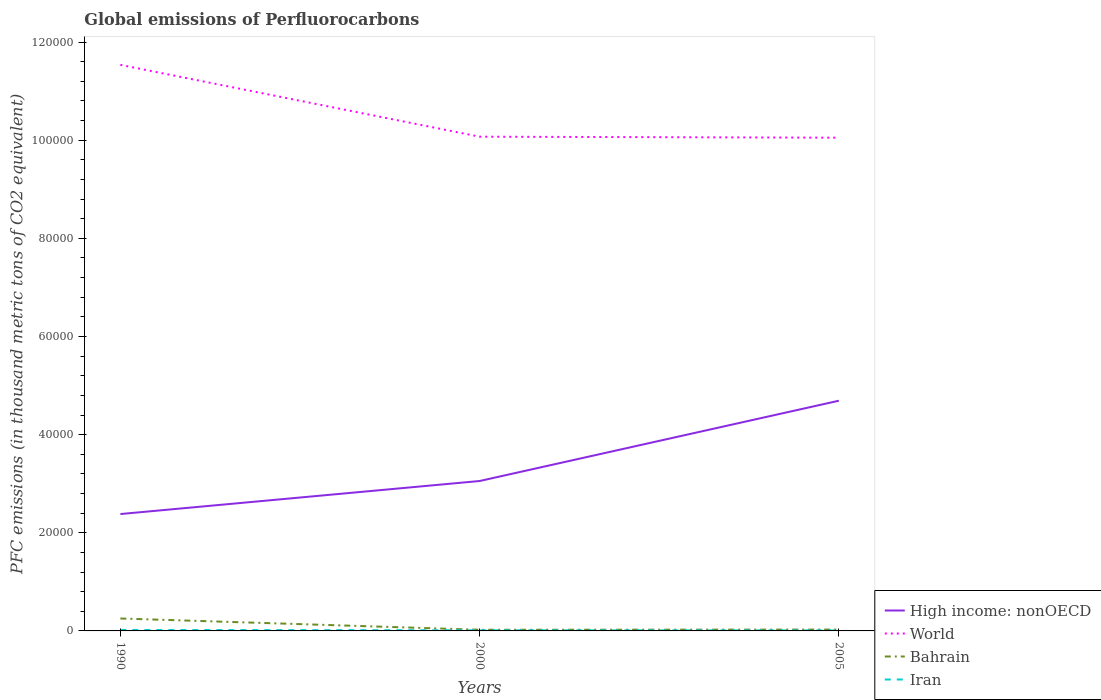Is the number of lines equal to the number of legend labels?
Ensure brevity in your answer.  Yes. Across all years, what is the maximum global emissions of Perfluorocarbons in Bahrain?
Make the answer very short. 236.1. What is the total global emissions of Perfluorocarbons in World in the graph?
Give a very brief answer. 1.46e+04. What is the difference between the highest and the second highest global emissions of Perfluorocarbons in High income: nonOECD?
Make the answer very short. 2.31e+04. Is the global emissions of Perfluorocarbons in Iran strictly greater than the global emissions of Perfluorocarbons in Bahrain over the years?
Keep it short and to the point. Yes. How many years are there in the graph?
Give a very brief answer. 3. Are the values on the major ticks of Y-axis written in scientific E-notation?
Offer a terse response. No. Does the graph contain grids?
Provide a short and direct response. No. How many legend labels are there?
Give a very brief answer. 4. What is the title of the graph?
Offer a very short reply. Global emissions of Perfluorocarbons. Does "Malaysia" appear as one of the legend labels in the graph?
Keep it short and to the point. No. What is the label or title of the Y-axis?
Give a very brief answer. PFC emissions (in thousand metric tons of CO2 equivalent). What is the PFC emissions (in thousand metric tons of CO2 equivalent) in High income: nonOECD in 1990?
Ensure brevity in your answer.  2.38e+04. What is the PFC emissions (in thousand metric tons of CO2 equivalent) of World in 1990?
Ensure brevity in your answer.  1.15e+05. What is the PFC emissions (in thousand metric tons of CO2 equivalent) in Bahrain in 1990?
Provide a succinct answer. 2535.7. What is the PFC emissions (in thousand metric tons of CO2 equivalent) in Iran in 1990?
Your answer should be compact. 203.5. What is the PFC emissions (in thousand metric tons of CO2 equivalent) of High income: nonOECD in 2000?
Offer a very short reply. 3.06e+04. What is the PFC emissions (in thousand metric tons of CO2 equivalent) of World in 2000?
Offer a very short reply. 1.01e+05. What is the PFC emissions (in thousand metric tons of CO2 equivalent) of Bahrain in 2000?
Offer a very short reply. 236.1. What is the PFC emissions (in thousand metric tons of CO2 equivalent) of Iran in 2000?
Keep it short and to the point. 128.5. What is the PFC emissions (in thousand metric tons of CO2 equivalent) in High income: nonOECD in 2005?
Offer a terse response. 4.69e+04. What is the PFC emissions (in thousand metric tons of CO2 equivalent) in World in 2005?
Your answer should be very brief. 1.01e+05. What is the PFC emissions (in thousand metric tons of CO2 equivalent) in Bahrain in 2005?
Offer a terse response. 278.6. What is the PFC emissions (in thousand metric tons of CO2 equivalent) in Iran in 2005?
Your answer should be very brief. 108.5. Across all years, what is the maximum PFC emissions (in thousand metric tons of CO2 equivalent) of High income: nonOECD?
Offer a terse response. 4.69e+04. Across all years, what is the maximum PFC emissions (in thousand metric tons of CO2 equivalent) in World?
Provide a succinct answer. 1.15e+05. Across all years, what is the maximum PFC emissions (in thousand metric tons of CO2 equivalent) of Bahrain?
Provide a succinct answer. 2535.7. Across all years, what is the maximum PFC emissions (in thousand metric tons of CO2 equivalent) in Iran?
Keep it short and to the point. 203.5. Across all years, what is the minimum PFC emissions (in thousand metric tons of CO2 equivalent) in High income: nonOECD?
Make the answer very short. 2.38e+04. Across all years, what is the minimum PFC emissions (in thousand metric tons of CO2 equivalent) of World?
Your answer should be very brief. 1.01e+05. Across all years, what is the minimum PFC emissions (in thousand metric tons of CO2 equivalent) of Bahrain?
Give a very brief answer. 236.1. Across all years, what is the minimum PFC emissions (in thousand metric tons of CO2 equivalent) of Iran?
Provide a succinct answer. 108.5. What is the total PFC emissions (in thousand metric tons of CO2 equivalent) in High income: nonOECD in the graph?
Keep it short and to the point. 1.01e+05. What is the total PFC emissions (in thousand metric tons of CO2 equivalent) in World in the graph?
Keep it short and to the point. 3.17e+05. What is the total PFC emissions (in thousand metric tons of CO2 equivalent) of Bahrain in the graph?
Provide a short and direct response. 3050.4. What is the total PFC emissions (in thousand metric tons of CO2 equivalent) of Iran in the graph?
Your answer should be compact. 440.5. What is the difference between the PFC emissions (in thousand metric tons of CO2 equivalent) of High income: nonOECD in 1990 and that in 2000?
Your response must be concise. -6731.3. What is the difference between the PFC emissions (in thousand metric tons of CO2 equivalent) of World in 1990 and that in 2000?
Keep it short and to the point. 1.46e+04. What is the difference between the PFC emissions (in thousand metric tons of CO2 equivalent) in Bahrain in 1990 and that in 2000?
Ensure brevity in your answer.  2299.6. What is the difference between the PFC emissions (in thousand metric tons of CO2 equivalent) in High income: nonOECD in 1990 and that in 2005?
Your answer should be very brief. -2.31e+04. What is the difference between the PFC emissions (in thousand metric tons of CO2 equivalent) of World in 1990 and that in 2005?
Provide a succinct answer. 1.48e+04. What is the difference between the PFC emissions (in thousand metric tons of CO2 equivalent) of Bahrain in 1990 and that in 2005?
Your answer should be very brief. 2257.1. What is the difference between the PFC emissions (in thousand metric tons of CO2 equivalent) in Iran in 1990 and that in 2005?
Offer a terse response. 95. What is the difference between the PFC emissions (in thousand metric tons of CO2 equivalent) of High income: nonOECD in 2000 and that in 2005?
Keep it short and to the point. -1.64e+04. What is the difference between the PFC emissions (in thousand metric tons of CO2 equivalent) of World in 2000 and that in 2005?
Make the answer very short. 203. What is the difference between the PFC emissions (in thousand metric tons of CO2 equivalent) of Bahrain in 2000 and that in 2005?
Your response must be concise. -42.5. What is the difference between the PFC emissions (in thousand metric tons of CO2 equivalent) in Iran in 2000 and that in 2005?
Keep it short and to the point. 20. What is the difference between the PFC emissions (in thousand metric tons of CO2 equivalent) in High income: nonOECD in 1990 and the PFC emissions (in thousand metric tons of CO2 equivalent) in World in 2000?
Your response must be concise. -7.69e+04. What is the difference between the PFC emissions (in thousand metric tons of CO2 equivalent) in High income: nonOECD in 1990 and the PFC emissions (in thousand metric tons of CO2 equivalent) in Bahrain in 2000?
Offer a terse response. 2.36e+04. What is the difference between the PFC emissions (in thousand metric tons of CO2 equivalent) in High income: nonOECD in 1990 and the PFC emissions (in thousand metric tons of CO2 equivalent) in Iran in 2000?
Your answer should be very brief. 2.37e+04. What is the difference between the PFC emissions (in thousand metric tons of CO2 equivalent) of World in 1990 and the PFC emissions (in thousand metric tons of CO2 equivalent) of Bahrain in 2000?
Make the answer very short. 1.15e+05. What is the difference between the PFC emissions (in thousand metric tons of CO2 equivalent) of World in 1990 and the PFC emissions (in thousand metric tons of CO2 equivalent) of Iran in 2000?
Offer a terse response. 1.15e+05. What is the difference between the PFC emissions (in thousand metric tons of CO2 equivalent) of Bahrain in 1990 and the PFC emissions (in thousand metric tons of CO2 equivalent) of Iran in 2000?
Your answer should be compact. 2407.2. What is the difference between the PFC emissions (in thousand metric tons of CO2 equivalent) of High income: nonOECD in 1990 and the PFC emissions (in thousand metric tons of CO2 equivalent) of World in 2005?
Your answer should be compact. -7.67e+04. What is the difference between the PFC emissions (in thousand metric tons of CO2 equivalent) of High income: nonOECD in 1990 and the PFC emissions (in thousand metric tons of CO2 equivalent) of Bahrain in 2005?
Your response must be concise. 2.35e+04. What is the difference between the PFC emissions (in thousand metric tons of CO2 equivalent) in High income: nonOECD in 1990 and the PFC emissions (in thousand metric tons of CO2 equivalent) in Iran in 2005?
Give a very brief answer. 2.37e+04. What is the difference between the PFC emissions (in thousand metric tons of CO2 equivalent) of World in 1990 and the PFC emissions (in thousand metric tons of CO2 equivalent) of Bahrain in 2005?
Your response must be concise. 1.15e+05. What is the difference between the PFC emissions (in thousand metric tons of CO2 equivalent) of World in 1990 and the PFC emissions (in thousand metric tons of CO2 equivalent) of Iran in 2005?
Provide a short and direct response. 1.15e+05. What is the difference between the PFC emissions (in thousand metric tons of CO2 equivalent) in Bahrain in 1990 and the PFC emissions (in thousand metric tons of CO2 equivalent) in Iran in 2005?
Provide a succinct answer. 2427.2. What is the difference between the PFC emissions (in thousand metric tons of CO2 equivalent) in High income: nonOECD in 2000 and the PFC emissions (in thousand metric tons of CO2 equivalent) in World in 2005?
Provide a short and direct response. -7.00e+04. What is the difference between the PFC emissions (in thousand metric tons of CO2 equivalent) of High income: nonOECD in 2000 and the PFC emissions (in thousand metric tons of CO2 equivalent) of Bahrain in 2005?
Your response must be concise. 3.03e+04. What is the difference between the PFC emissions (in thousand metric tons of CO2 equivalent) of High income: nonOECD in 2000 and the PFC emissions (in thousand metric tons of CO2 equivalent) of Iran in 2005?
Your response must be concise. 3.04e+04. What is the difference between the PFC emissions (in thousand metric tons of CO2 equivalent) of World in 2000 and the PFC emissions (in thousand metric tons of CO2 equivalent) of Bahrain in 2005?
Provide a succinct answer. 1.00e+05. What is the difference between the PFC emissions (in thousand metric tons of CO2 equivalent) of World in 2000 and the PFC emissions (in thousand metric tons of CO2 equivalent) of Iran in 2005?
Your answer should be compact. 1.01e+05. What is the difference between the PFC emissions (in thousand metric tons of CO2 equivalent) of Bahrain in 2000 and the PFC emissions (in thousand metric tons of CO2 equivalent) of Iran in 2005?
Your answer should be compact. 127.6. What is the average PFC emissions (in thousand metric tons of CO2 equivalent) of High income: nonOECD per year?
Offer a very short reply. 3.38e+04. What is the average PFC emissions (in thousand metric tons of CO2 equivalent) in World per year?
Offer a very short reply. 1.06e+05. What is the average PFC emissions (in thousand metric tons of CO2 equivalent) of Bahrain per year?
Provide a short and direct response. 1016.8. What is the average PFC emissions (in thousand metric tons of CO2 equivalent) of Iran per year?
Provide a succinct answer. 146.83. In the year 1990, what is the difference between the PFC emissions (in thousand metric tons of CO2 equivalent) in High income: nonOECD and PFC emissions (in thousand metric tons of CO2 equivalent) in World?
Make the answer very short. -9.15e+04. In the year 1990, what is the difference between the PFC emissions (in thousand metric tons of CO2 equivalent) of High income: nonOECD and PFC emissions (in thousand metric tons of CO2 equivalent) of Bahrain?
Keep it short and to the point. 2.13e+04. In the year 1990, what is the difference between the PFC emissions (in thousand metric tons of CO2 equivalent) in High income: nonOECD and PFC emissions (in thousand metric tons of CO2 equivalent) in Iran?
Provide a short and direct response. 2.36e+04. In the year 1990, what is the difference between the PFC emissions (in thousand metric tons of CO2 equivalent) of World and PFC emissions (in thousand metric tons of CO2 equivalent) of Bahrain?
Your answer should be very brief. 1.13e+05. In the year 1990, what is the difference between the PFC emissions (in thousand metric tons of CO2 equivalent) of World and PFC emissions (in thousand metric tons of CO2 equivalent) of Iran?
Your response must be concise. 1.15e+05. In the year 1990, what is the difference between the PFC emissions (in thousand metric tons of CO2 equivalent) in Bahrain and PFC emissions (in thousand metric tons of CO2 equivalent) in Iran?
Keep it short and to the point. 2332.2. In the year 2000, what is the difference between the PFC emissions (in thousand metric tons of CO2 equivalent) of High income: nonOECD and PFC emissions (in thousand metric tons of CO2 equivalent) of World?
Your answer should be compact. -7.02e+04. In the year 2000, what is the difference between the PFC emissions (in thousand metric tons of CO2 equivalent) in High income: nonOECD and PFC emissions (in thousand metric tons of CO2 equivalent) in Bahrain?
Offer a very short reply. 3.03e+04. In the year 2000, what is the difference between the PFC emissions (in thousand metric tons of CO2 equivalent) of High income: nonOECD and PFC emissions (in thousand metric tons of CO2 equivalent) of Iran?
Offer a terse response. 3.04e+04. In the year 2000, what is the difference between the PFC emissions (in thousand metric tons of CO2 equivalent) in World and PFC emissions (in thousand metric tons of CO2 equivalent) in Bahrain?
Your answer should be compact. 1.00e+05. In the year 2000, what is the difference between the PFC emissions (in thousand metric tons of CO2 equivalent) of World and PFC emissions (in thousand metric tons of CO2 equivalent) of Iran?
Your answer should be compact. 1.01e+05. In the year 2000, what is the difference between the PFC emissions (in thousand metric tons of CO2 equivalent) in Bahrain and PFC emissions (in thousand metric tons of CO2 equivalent) in Iran?
Your answer should be compact. 107.6. In the year 2005, what is the difference between the PFC emissions (in thousand metric tons of CO2 equivalent) in High income: nonOECD and PFC emissions (in thousand metric tons of CO2 equivalent) in World?
Ensure brevity in your answer.  -5.36e+04. In the year 2005, what is the difference between the PFC emissions (in thousand metric tons of CO2 equivalent) in High income: nonOECD and PFC emissions (in thousand metric tons of CO2 equivalent) in Bahrain?
Provide a succinct answer. 4.66e+04. In the year 2005, what is the difference between the PFC emissions (in thousand metric tons of CO2 equivalent) in High income: nonOECD and PFC emissions (in thousand metric tons of CO2 equivalent) in Iran?
Ensure brevity in your answer.  4.68e+04. In the year 2005, what is the difference between the PFC emissions (in thousand metric tons of CO2 equivalent) in World and PFC emissions (in thousand metric tons of CO2 equivalent) in Bahrain?
Keep it short and to the point. 1.00e+05. In the year 2005, what is the difference between the PFC emissions (in thousand metric tons of CO2 equivalent) in World and PFC emissions (in thousand metric tons of CO2 equivalent) in Iran?
Offer a very short reply. 1.00e+05. In the year 2005, what is the difference between the PFC emissions (in thousand metric tons of CO2 equivalent) in Bahrain and PFC emissions (in thousand metric tons of CO2 equivalent) in Iran?
Give a very brief answer. 170.1. What is the ratio of the PFC emissions (in thousand metric tons of CO2 equivalent) of High income: nonOECD in 1990 to that in 2000?
Ensure brevity in your answer.  0.78. What is the ratio of the PFC emissions (in thousand metric tons of CO2 equivalent) in World in 1990 to that in 2000?
Your answer should be compact. 1.15. What is the ratio of the PFC emissions (in thousand metric tons of CO2 equivalent) in Bahrain in 1990 to that in 2000?
Give a very brief answer. 10.74. What is the ratio of the PFC emissions (in thousand metric tons of CO2 equivalent) in Iran in 1990 to that in 2000?
Ensure brevity in your answer.  1.58. What is the ratio of the PFC emissions (in thousand metric tons of CO2 equivalent) of High income: nonOECD in 1990 to that in 2005?
Your response must be concise. 0.51. What is the ratio of the PFC emissions (in thousand metric tons of CO2 equivalent) in World in 1990 to that in 2005?
Your response must be concise. 1.15. What is the ratio of the PFC emissions (in thousand metric tons of CO2 equivalent) of Bahrain in 1990 to that in 2005?
Your answer should be compact. 9.1. What is the ratio of the PFC emissions (in thousand metric tons of CO2 equivalent) in Iran in 1990 to that in 2005?
Your response must be concise. 1.88. What is the ratio of the PFC emissions (in thousand metric tons of CO2 equivalent) of High income: nonOECD in 2000 to that in 2005?
Your answer should be compact. 0.65. What is the ratio of the PFC emissions (in thousand metric tons of CO2 equivalent) of World in 2000 to that in 2005?
Keep it short and to the point. 1. What is the ratio of the PFC emissions (in thousand metric tons of CO2 equivalent) of Bahrain in 2000 to that in 2005?
Offer a terse response. 0.85. What is the ratio of the PFC emissions (in thousand metric tons of CO2 equivalent) of Iran in 2000 to that in 2005?
Give a very brief answer. 1.18. What is the difference between the highest and the second highest PFC emissions (in thousand metric tons of CO2 equivalent) in High income: nonOECD?
Offer a terse response. 1.64e+04. What is the difference between the highest and the second highest PFC emissions (in thousand metric tons of CO2 equivalent) of World?
Provide a succinct answer. 1.46e+04. What is the difference between the highest and the second highest PFC emissions (in thousand metric tons of CO2 equivalent) of Bahrain?
Give a very brief answer. 2257.1. What is the difference between the highest and the second highest PFC emissions (in thousand metric tons of CO2 equivalent) of Iran?
Provide a succinct answer. 75. What is the difference between the highest and the lowest PFC emissions (in thousand metric tons of CO2 equivalent) of High income: nonOECD?
Keep it short and to the point. 2.31e+04. What is the difference between the highest and the lowest PFC emissions (in thousand metric tons of CO2 equivalent) of World?
Ensure brevity in your answer.  1.48e+04. What is the difference between the highest and the lowest PFC emissions (in thousand metric tons of CO2 equivalent) of Bahrain?
Provide a succinct answer. 2299.6. 